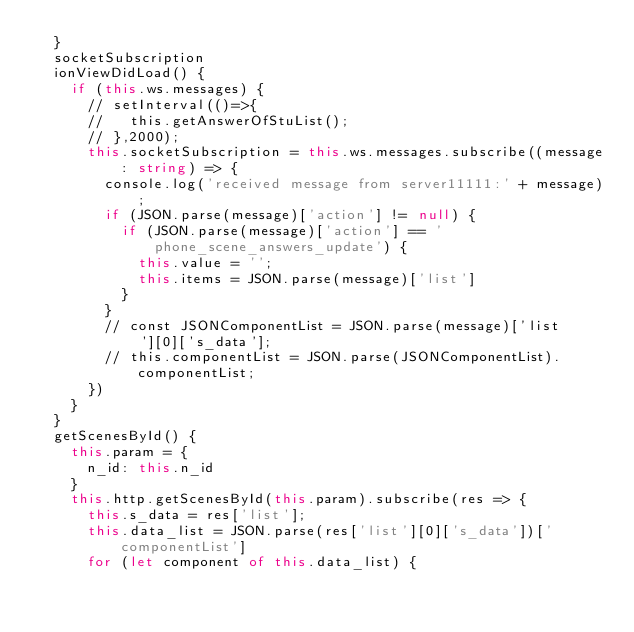Convert code to text. <code><loc_0><loc_0><loc_500><loc_500><_TypeScript_>  }
  socketSubscription
  ionViewDidLoad() {
    if (this.ws.messages) {
      // setInterval(()=>{
      //   this.getAnswerOfStuList();
      // },2000);
      this.socketSubscription = this.ws.messages.subscribe((message: string) => {
        console.log('received message from server11111:' + message);
        if (JSON.parse(message)['action'] != null) {
          if (JSON.parse(message)['action'] == 'phone_scene_answers_update') {
            this.value = '';
            this.items = JSON.parse(message)['list']
          }
        }
        // const JSONComponentList = JSON.parse(message)['list'][0]['s_data'];
        // this.componentList = JSON.parse(JSONComponentList).componentList;
      })
    }
  }
  getScenesById() {
    this.param = {
      n_id: this.n_id
    }
    this.http.getScenesById(this.param).subscribe(res => {
      this.s_data = res['list'];
      this.data_list = JSON.parse(res['list'][0]['s_data'])['componentList']
      for (let component of this.data_list) {</code> 